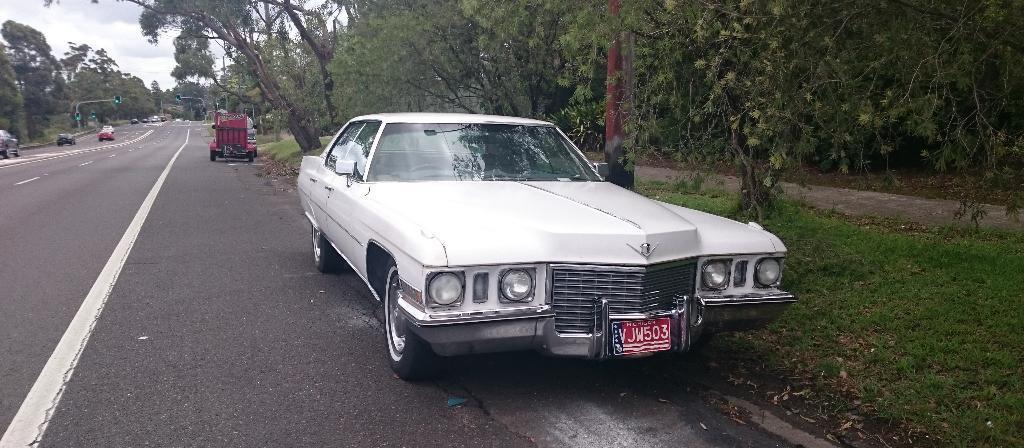Describe this image in one or two sentences. In this image I can see vehicles on the road. In the background I can see trees, the grass, traffic lights and the sky. Here I can see white lines on the road. 